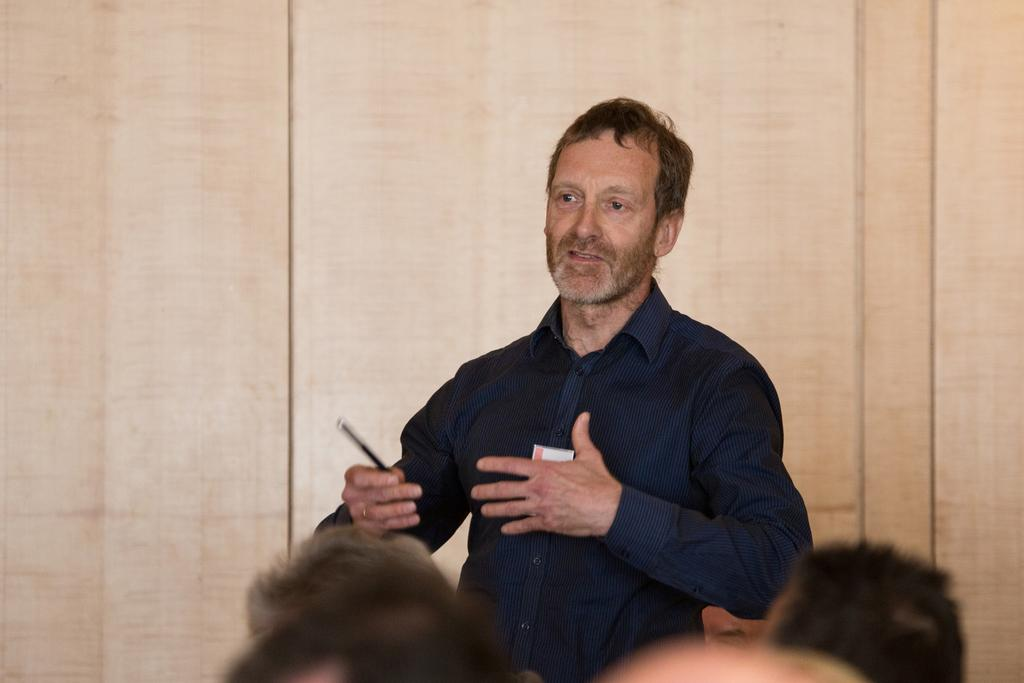What is the main subject of the image? There is a man standing in the center of the image. What is the man holding in the image? The man is holding a pen. What can be seen in the background of the image? There is a wall in the background of the image. Are there any other people visible in the image? Yes, there are people at the bottom of the image. Reasoning: Let'g: Let's think step by step in order to produce the conversation. We start by identifying the main subject of the image, which is the man standing in the center. Then, we describe what the man is holding, which is a pen. Next, we mention the background of the image, which features a wall. Finally, we acknowledge the presence of other people in the image, who are located at the bottom. Absurd Question/Answer: What type of toothbrush is the man using in the image? There is no toothbrush present in the image; the man is holding a pen. How many chairs are visible in the image? There are no chairs visible in the image. 